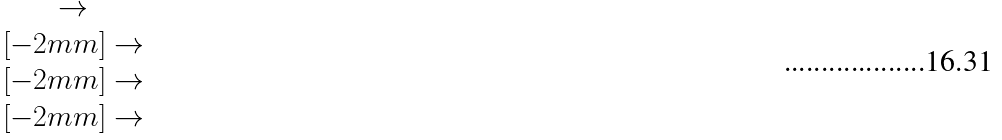Convert formula to latex. <formula><loc_0><loc_0><loc_500><loc_500>\begin{matrix} \to \\ [ - 2 m m ] \to \\ [ - 2 m m ] \to \\ [ - 2 m m ] \to \end{matrix}</formula> 